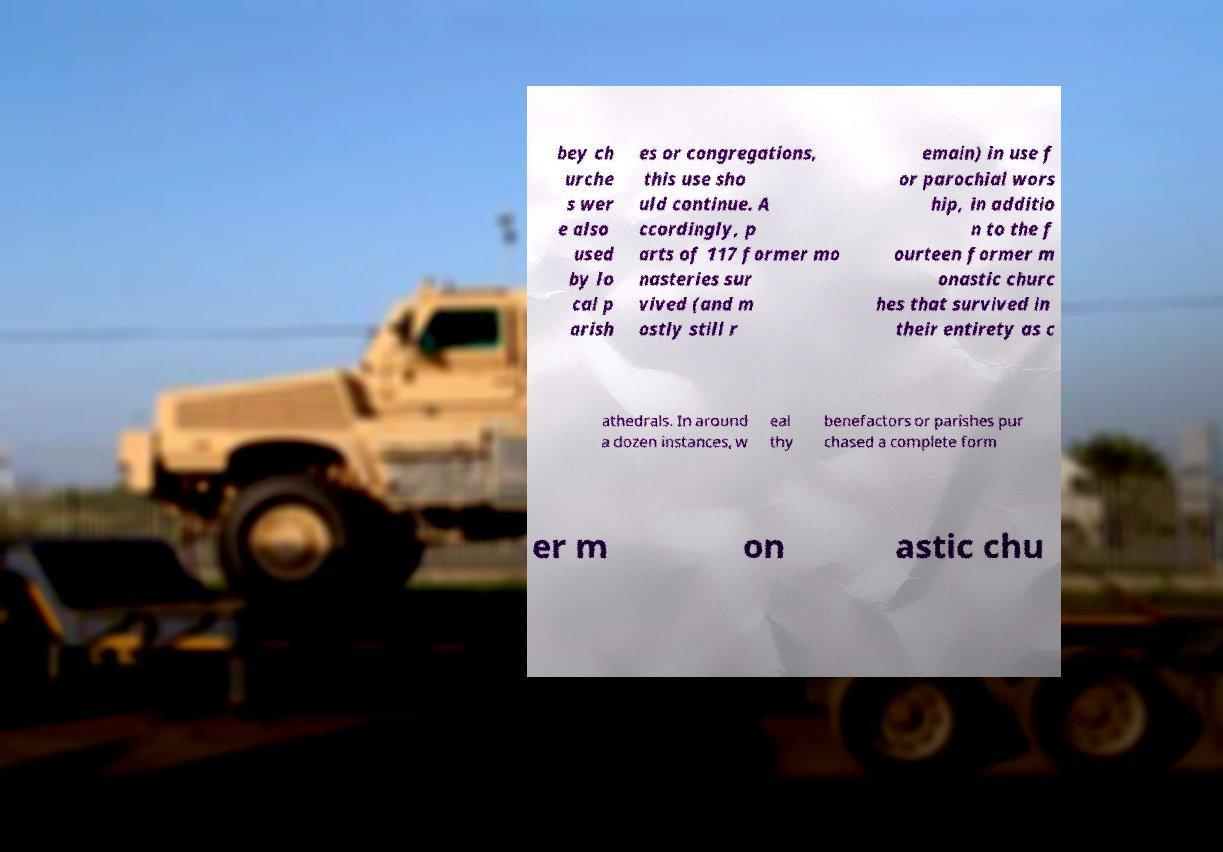Can you accurately transcribe the text from the provided image for me? bey ch urche s wer e also used by lo cal p arish es or congregations, this use sho uld continue. A ccordingly, p arts of 117 former mo nasteries sur vived (and m ostly still r emain) in use f or parochial wors hip, in additio n to the f ourteen former m onastic churc hes that survived in their entirety as c athedrals. In around a dozen instances, w eal thy benefactors or parishes pur chased a complete form er m on astic chu 